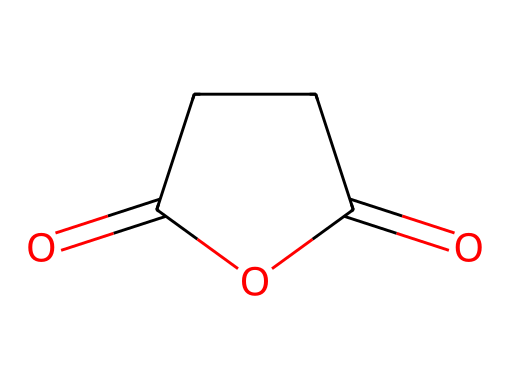What is the molecular formula of succinic anhydride? To determine the molecular formula, we count the atoms present in the structure. The structure indicates that there are 4 carbon atoms, 4 hydrogen atoms, and 2 oxygen atoms. Therefore, the molecular formula is C4H4O2.
Answer: C4H4O2 How many carbon atoms are present in succinic anhydride? By observing the rendered structure, we can see 4 distinct carbon atoms in the molecular arrangement.
Answer: 4 What type of functional groups are present in succinic anhydride? The structure shows the presence of two carbonyl (C=O) groups, which are characteristic of anhydrides. Therefore, the main functional group is an anhydride.
Answer: anhydride What is the total number of oxygen atoms in the structure? From inspection of the structure, there are 2 oxygen atoms present, clearly visible in the two carbonyl groups.
Answer: 2 What is the chemical classification of succinic anhydride? Based on its structure, succinic anhydride fits the classification of an acid anhydride, as it is derived from a dicarboxylic acid (succinic acid).
Answer: acid anhydride What is the significance of the cyclic arrangement of succinic anhydride? The cyclic structure of succinic anhydride allows it to form a stable anhydride from a dicarboxylic acid by the removal of water. This structural property enhances its reactivity in chemical synthesis and applications in pharmaceuticals and cosmetics.
Answer: stability and reactivity 